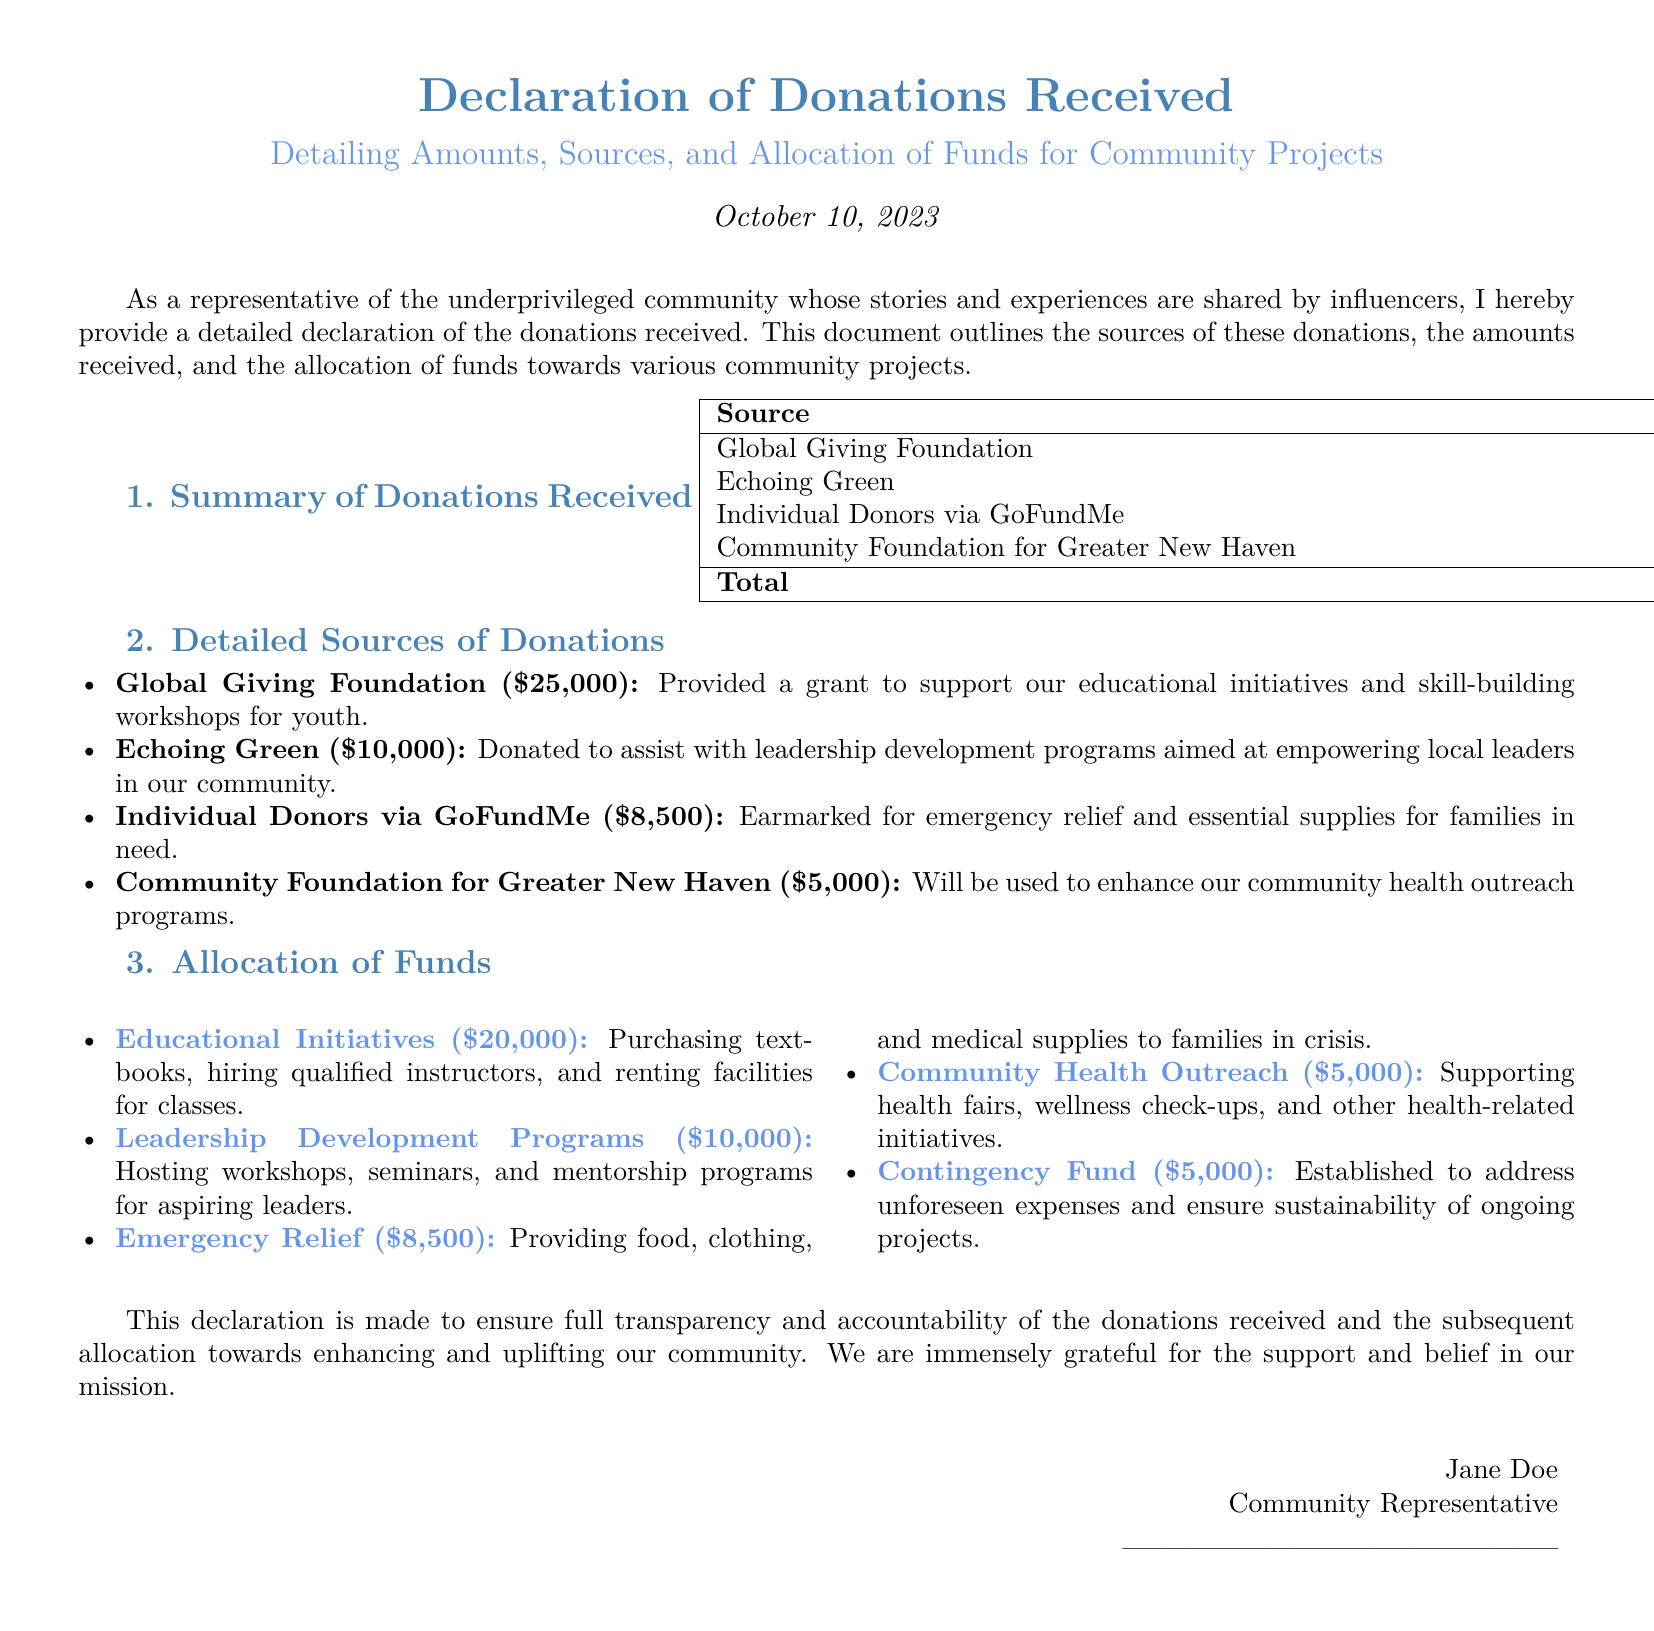What is the total amount of donations received? The total amount of donations is the sum of all donations listed in the document, which amounts to $25,000 + $10,000 + $8,500 + $5,000 = $48,500.
Answer: $48,500 Who contributed the largest donation? The largest donation of $25,000 came from the Global Giving Foundation.
Answer: Global Giving Foundation How much was allocated to emergency relief? The allocation for emergency relief is specified in the document as $8,500.
Answer: $8,500 What initiative received funding from Echoing Green? The Echoing Green contribution of $10,000 is allocated for leadership development programs.
Answer: Leadership development programs What is the purpose of the contingency fund? The contingency fund is established to address unforeseen expenses and ensure project sustainability.
Answer: Address unforeseen expenses How much funding was targeted for community health outreach? The amount earmarked for community health outreach is $5,000.
Answer: $5,000 What date was this declaration made? The declaration was made on October 10, 2023, as mentioned in the document.
Answer: October 10, 2023 What is the total allocation for educational initiatives? The total amount allocated for educational initiatives is $20,000.
Answer: $20,000 